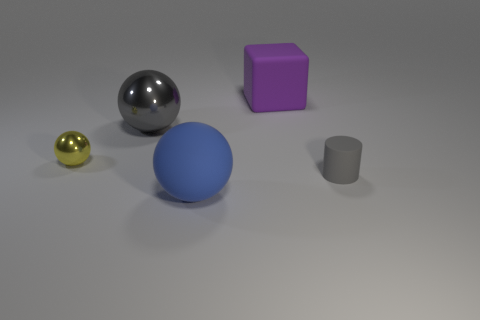The tiny metal sphere has what color?
Your answer should be very brief. Yellow. There is a matte cylinder that is the same size as the yellow ball; what color is it?
Give a very brief answer. Gray. There is a matte object that is left of the large purple matte object; is it the same shape as the tiny yellow shiny thing?
Offer a terse response. Yes. There is a rubber object that is to the left of the big thing that is behind the gray object that is left of the blue matte object; what color is it?
Ensure brevity in your answer.  Blue. Are there any brown matte spheres?
Make the answer very short. No. How many other objects are the same size as the gray metal sphere?
Your answer should be compact. 2. There is a tiny matte cylinder; is its color the same as the big sphere behind the tiny gray rubber cylinder?
Offer a very short reply. Yes. How many objects are tiny brown things or tiny metal things?
Keep it short and to the point. 1. Are there any other things that are the same color as the big rubber ball?
Your answer should be compact. No. Is the material of the large blue ball the same as the gray object that is left of the purple rubber thing?
Offer a very short reply. No. 